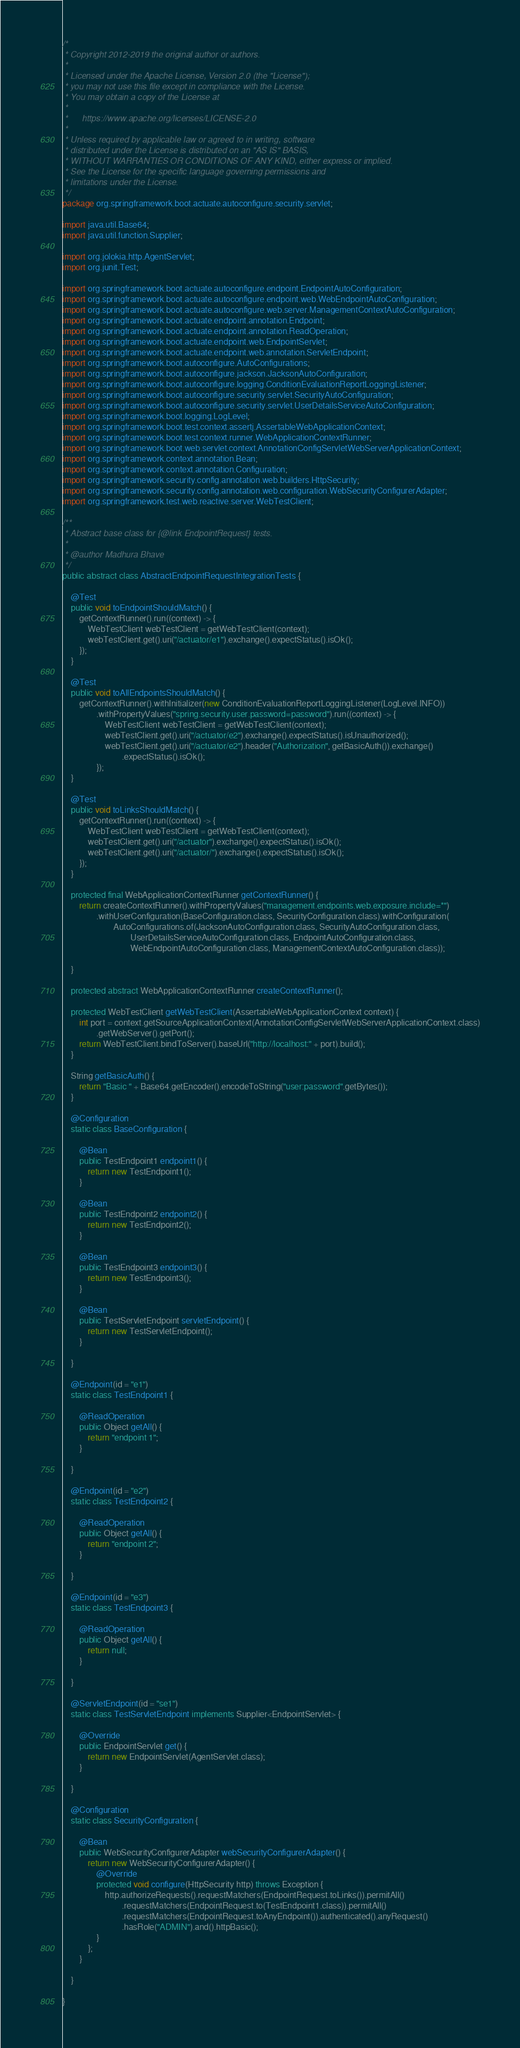Convert code to text. <code><loc_0><loc_0><loc_500><loc_500><_Java_>/*
 * Copyright 2012-2019 the original author or authors.
 *
 * Licensed under the Apache License, Version 2.0 (the "License");
 * you may not use this file except in compliance with the License.
 * You may obtain a copy of the License at
 *
 *      https://www.apache.org/licenses/LICENSE-2.0
 *
 * Unless required by applicable law or agreed to in writing, software
 * distributed under the License is distributed on an "AS IS" BASIS,
 * WITHOUT WARRANTIES OR CONDITIONS OF ANY KIND, either express or implied.
 * See the License for the specific language governing permissions and
 * limitations under the License.
 */
package org.springframework.boot.actuate.autoconfigure.security.servlet;

import java.util.Base64;
import java.util.function.Supplier;

import org.jolokia.http.AgentServlet;
import org.junit.Test;

import org.springframework.boot.actuate.autoconfigure.endpoint.EndpointAutoConfiguration;
import org.springframework.boot.actuate.autoconfigure.endpoint.web.WebEndpointAutoConfiguration;
import org.springframework.boot.actuate.autoconfigure.web.server.ManagementContextAutoConfiguration;
import org.springframework.boot.actuate.endpoint.annotation.Endpoint;
import org.springframework.boot.actuate.endpoint.annotation.ReadOperation;
import org.springframework.boot.actuate.endpoint.web.EndpointServlet;
import org.springframework.boot.actuate.endpoint.web.annotation.ServletEndpoint;
import org.springframework.boot.autoconfigure.AutoConfigurations;
import org.springframework.boot.autoconfigure.jackson.JacksonAutoConfiguration;
import org.springframework.boot.autoconfigure.logging.ConditionEvaluationReportLoggingListener;
import org.springframework.boot.autoconfigure.security.servlet.SecurityAutoConfiguration;
import org.springframework.boot.autoconfigure.security.servlet.UserDetailsServiceAutoConfiguration;
import org.springframework.boot.logging.LogLevel;
import org.springframework.boot.test.context.assertj.AssertableWebApplicationContext;
import org.springframework.boot.test.context.runner.WebApplicationContextRunner;
import org.springframework.boot.web.servlet.context.AnnotationConfigServletWebServerApplicationContext;
import org.springframework.context.annotation.Bean;
import org.springframework.context.annotation.Configuration;
import org.springframework.security.config.annotation.web.builders.HttpSecurity;
import org.springframework.security.config.annotation.web.configuration.WebSecurityConfigurerAdapter;
import org.springframework.test.web.reactive.server.WebTestClient;

/**
 * Abstract base class for {@link EndpointRequest} tests.
 *
 * @author Madhura Bhave
 */
public abstract class AbstractEndpointRequestIntegrationTests {

	@Test
	public void toEndpointShouldMatch() {
		getContextRunner().run((context) -> {
			WebTestClient webTestClient = getWebTestClient(context);
			webTestClient.get().uri("/actuator/e1").exchange().expectStatus().isOk();
		});
	}

	@Test
	public void toAllEndpointsShouldMatch() {
		getContextRunner().withInitializer(new ConditionEvaluationReportLoggingListener(LogLevel.INFO))
				.withPropertyValues("spring.security.user.password=password").run((context) -> {
					WebTestClient webTestClient = getWebTestClient(context);
					webTestClient.get().uri("/actuator/e2").exchange().expectStatus().isUnauthorized();
					webTestClient.get().uri("/actuator/e2").header("Authorization", getBasicAuth()).exchange()
							.expectStatus().isOk();
				});
	}

	@Test
	public void toLinksShouldMatch() {
		getContextRunner().run((context) -> {
			WebTestClient webTestClient = getWebTestClient(context);
			webTestClient.get().uri("/actuator").exchange().expectStatus().isOk();
			webTestClient.get().uri("/actuator/").exchange().expectStatus().isOk();
		});
	}

	protected final WebApplicationContextRunner getContextRunner() {
		return createContextRunner().withPropertyValues("management.endpoints.web.exposure.include=*")
				.withUserConfiguration(BaseConfiguration.class, SecurityConfiguration.class).withConfiguration(
						AutoConfigurations.of(JacksonAutoConfiguration.class, SecurityAutoConfiguration.class,
								UserDetailsServiceAutoConfiguration.class, EndpointAutoConfiguration.class,
								WebEndpointAutoConfiguration.class, ManagementContextAutoConfiguration.class));

	}

	protected abstract WebApplicationContextRunner createContextRunner();

	protected WebTestClient getWebTestClient(AssertableWebApplicationContext context) {
		int port = context.getSourceApplicationContext(AnnotationConfigServletWebServerApplicationContext.class)
				.getWebServer().getPort();
		return WebTestClient.bindToServer().baseUrl("http://localhost:" + port).build();
	}

	String getBasicAuth() {
		return "Basic " + Base64.getEncoder().encodeToString("user:password".getBytes());
	}

	@Configuration
	static class BaseConfiguration {

		@Bean
		public TestEndpoint1 endpoint1() {
			return new TestEndpoint1();
		}

		@Bean
		public TestEndpoint2 endpoint2() {
			return new TestEndpoint2();
		}

		@Bean
		public TestEndpoint3 endpoint3() {
			return new TestEndpoint3();
		}

		@Bean
		public TestServletEndpoint servletEndpoint() {
			return new TestServletEndpoint();
		}

	}

	@Endpoint(id = "e1")
	static class TestEndpoint1 {

		@ReadOperation
		public Object getAll() {
			return "endpoint 1";
		}

	}

	@Endpoint(id = "e2")
	static class TestEndpoint2 {

		@ReadOperation
		public Object getAll() {
			return "endpoint 2";
		}

	}

	@Endpoint(id = "e3")
	static class TestEndpoint3 {

		@ReadOperation
		public Object getAll() {
			return null;
		}

	}

	@ServletEndpoint(id = "se1")
	static class TestServletEndpoint implements Supplier<EndpointServlet> {

		@Override
		public EndpointServlet get() {
			return new EndpointServlet(AgentServlet.class);
		}

	}

	@Configuration
	static class SecurityConfiguration {

		@Bean
		public WebSecurityConfigurerAdapter webSecurityConfigurerAdapter() {
			return new WebSecurityConfigurerAdapter() {
				@Override
				protected void configure(HttpSecurity http) throws Exception {
					http.authorizeRequests().requestMatchers(EndpointRequest.toLinks()).permitAll()
							.requestMatchers(EndpointRequest.to(TestEndpoint1.class)).permitAll()
							.requestMatchers(EndpointRequest.toAnyEndpoint()).authenticated().anyRequest()
							.hasRole("ADMIN").and().httpBasic();
				}
			};
		}

	}

}
</code> 